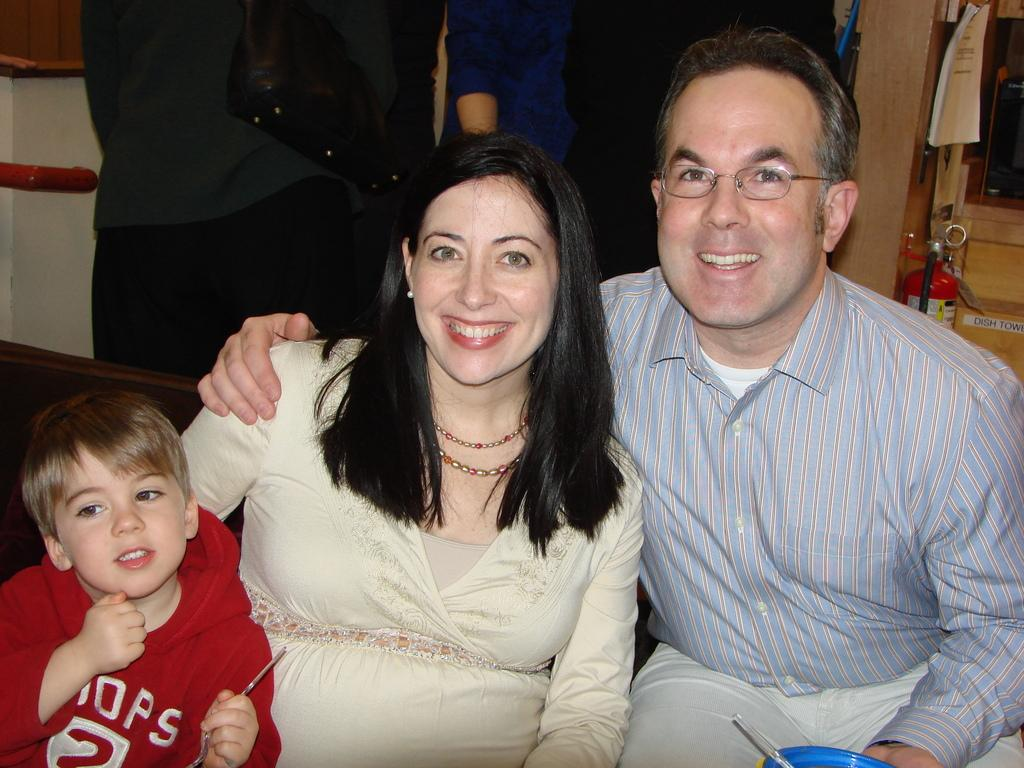How many people are in the image? There are three people in the image. What are the people in the image doing? The people are smiling. What can be seen in the background of the image? There is a fire extinguisher and people in the background of the image. What type of watch is the person in the image wearing? There is no watch visible on any of the people in the image. How does the fork affect the people in the image? There is no fork present in the image, so it cannot affect the people. 